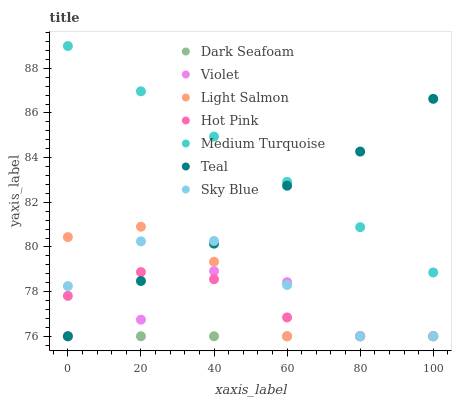Does Dark Seafoam have the minimum area under the curve?
Answer yes or no. Yes. Does Medium Turquoise have the maximum area under the curve?
Answer yes or no. Yes. Does Hot Pink have the minimum area under the curve?
Answer yes or no. No. Does Hot Pink have the maximum area under the curve?
Answer yes or no. No. Is Medium Turquoise the smoothest?
Answer yes or no. Yes. Is Violet the roughest?
Answer yes or no. Yes. Is Hot Pink the smoothest?
Answer yes or no. No. Is Hot Pink the roughest?
Answer yes or no. No. Does Light Salmon have the lowest value?
Answer yes or no. Yes. Does Medium Turquoise have the lowest value?
Answer yes or no. No. Does Medium Turquoise have the highest value?
Answer yes or no. Yes. Does Hot Pink have the highest value?
Answer yes or no. No. Is Sky Blue less than Medium Turquoise?
Answer yes or no. Yes. Is Medium Turquoise greater than Hot Pink?
Answer yes or no. Yes. Does Violet intersect Sky Blue?
Answer yes or no. Yes. Is Violet less than Sky Blue?
Answer yes or no. No. Is Violet greater than Sky Blue?
Answer yes or no. No. Does Sky Blue intersect Medium Turquoise?
Answer yes or no. No. 